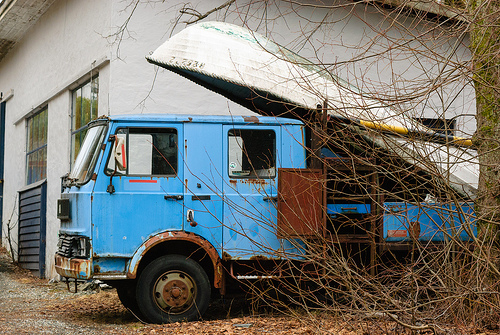<image>
Can you confirm if the boat is on the truck? Yes. Looking at the image, I can see the boat is positioned on top of the truck, with the truck providing support. 